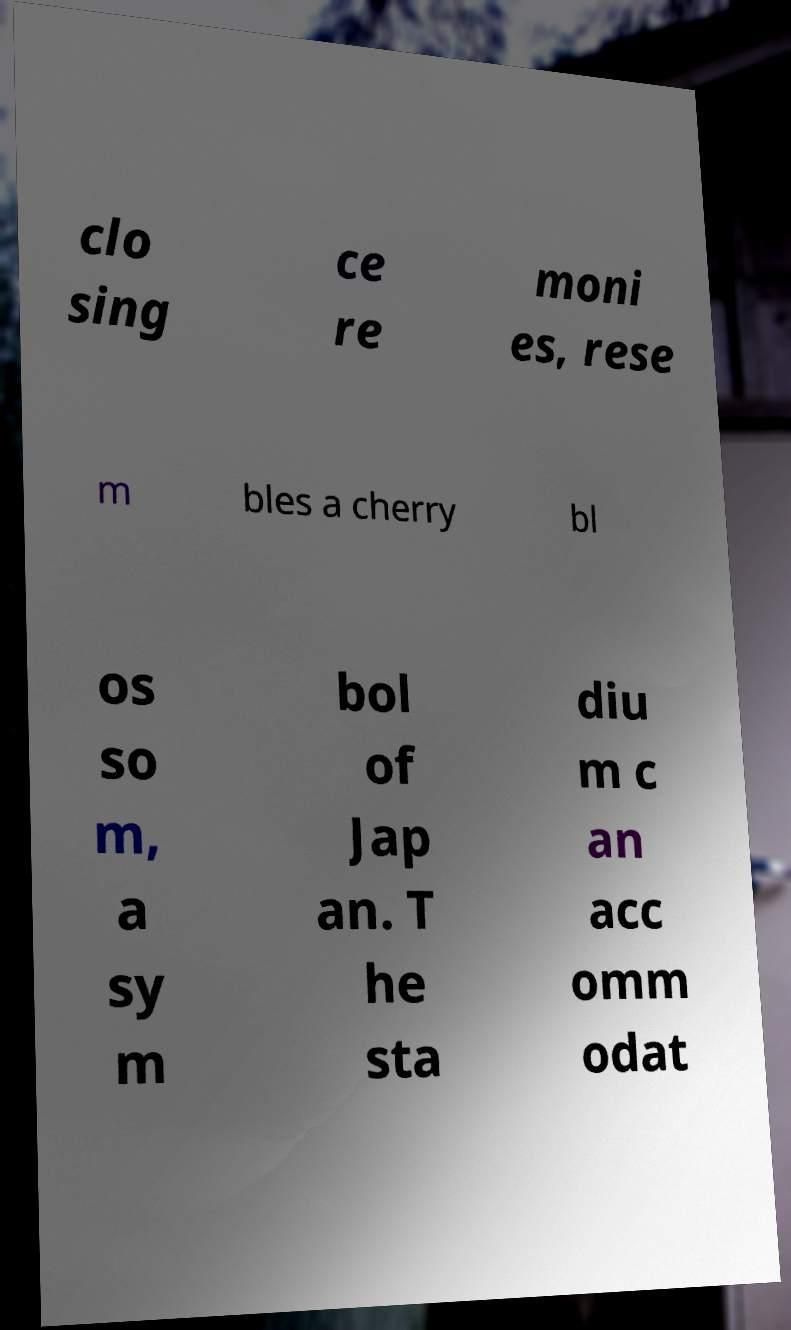Can you read and provide the text displayed in the image?This photo seems to have some interesting text. Can you extract and type it out for me? clo sing ce re moni es, rese m bles a cherry bl os so m, a sy m bol of Jap an. T he sta diu m c an acc omm odat 